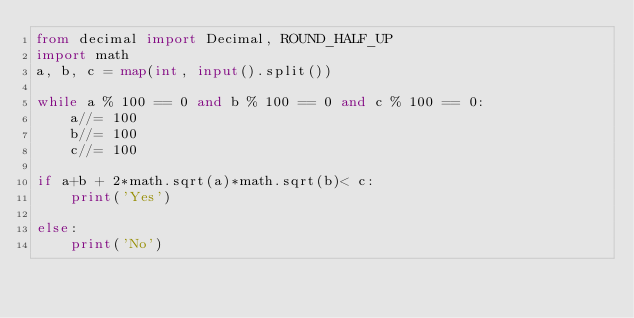<code> <loc_0><loc_0><loc_500><loc_500><_Python_>from decimal import Decimal, ROUND_HALF_UP
import math
a, b, c = map(int, input().split())

while a % 100 == 0 and b % 100 == 0 and c % 100 == 0:
    a//= 100
    b//= 100
    c//= 100

if a+b + 2*math.sqrt(a)*math.sqrt(b)< c:
    print('Yes')
    
else:
    print('No')
</code> 